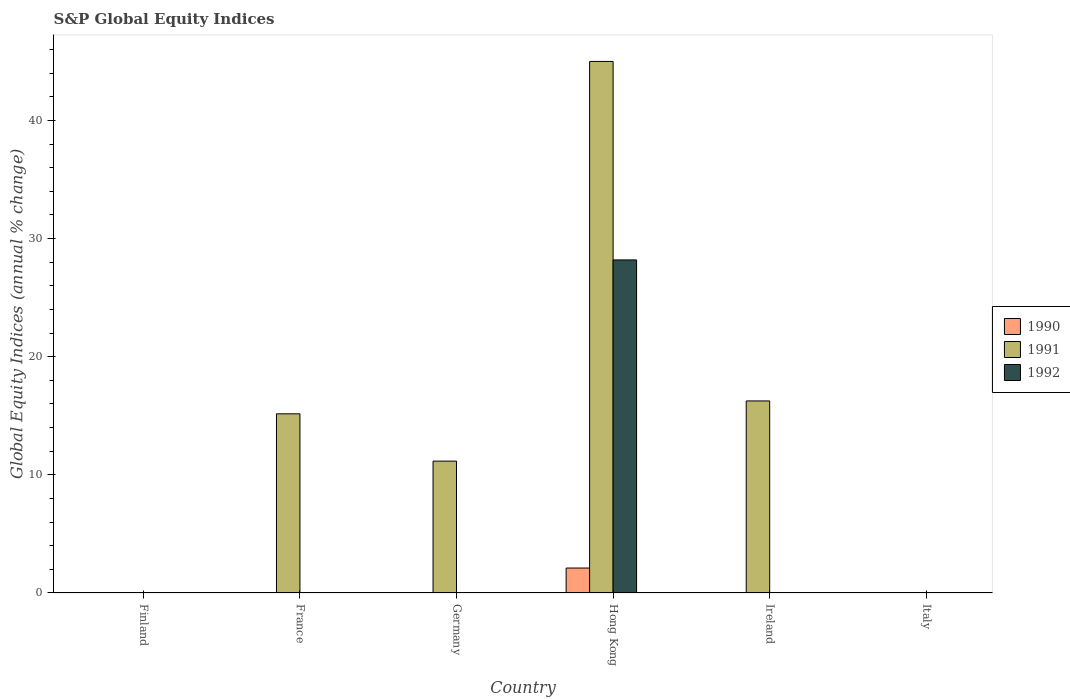Are the number of bars on each tick of the X-axis equal?
Provide a succinct answer. No. How many bars are there on the 4th tick from the left?
Your response must be concise. 3. How many bars are there on the 2nd tick from the right?
Your answer should be very brief. 1. What is the label of the 2nd group of bars from the left?
Your response must be concise. France. What is the global equity indices in 1990 in Italy?
Your answer should be very brief. 0. Across all countries, what is the maximum global equity indices in 1990?
Keep it short and to the point. 2.11. Across all countries, what is the minimum global equity indices in 1990?
Offer a terse response. 0. In which country was the global equity indices in 1991 maximum?
Provide a succinct answer. Hong Kong. What is the total global equity indices in 1992 in the graph?
Keep it short and to the point. 28.19. What is the difference between the global equity indices in 1991 in France and that in Hong Kong?
Offer a terse response. -29.83. What is the difference between the global equity indices in 1990 in Ireland and the global equity indices in 1992 in Hong Kong?
Offer a terse response. -28.19. What is the average global equity indices in 1990 per country?
Your response must be concise. 0.35. What is the difference between the global equity indices of/in 1990 and global equity indices of/in 1991 in Hong Kong?
Provide a succinct answer. -42.88. In how many countries, is the global equity indices in 1990 greater than 16 %?
Provide a succinct answer. 0. What is the ratio of the global equity indices in 1991 in France to that in Germany?
Provide a short and direct response. 1.36. Is the global equity indices in 1991 in France less than that in Hong Kong?
Your answer should be compact. Yes. What is the difference between the highest and the second highest global equity indices in 1991?
Provide a short and direct response. -28.74. What is the difference between the highest and the lowest global equity indices in 1990?
Offer a very short reply. 2.11. In how many countries, is the global equity indices in 1991 greater than the average global equity indices in 1991 taken over all countries?
Offer a terse response. 3. Is the sum of the global equity indices in 1991 in France and Germany greater than the maximum global equity indices in 1992 across all countries?
Your answer should be very brief. No. Is it the case that in every country, the sum of the global equity indices in 1992 and global equity indices in 1991 is greater than the global equity indices in 1990?
Provide a short and direct response. No. How many countries are there in the graph?
Your answer should be compact. 6. Are the values on the major ticks of Y-axis written in scientific E-notation?
Keep it short and to the point. No. Does the graph contain any zero values?
Your response must be concise. Yes. Does the graph contain grids?
Your response must be concise. No. Where does the legend appear in the graph?
Ensure brevity in your answer.  Center right. What is the title of the graph?
Offer a very short reply. S&P Global Equity Indices. Does "1969" appear as one of the legend labels in the graph?
Offer a terse response. No. What is the label or title of the X-axis?
Keep it short and to the point. Country. What is the label or title of the Y-axis?
Provide a succinct answer. Global Equity Indices (annual % change). What is the Global Equity Indices (annual % change) in 1990 in Finland?
Make the answer very short. 0. What is the Global Equity Indices (annual % change) in 1990 in France?
Your answer should be compact. 0. What is the Global Equity Indices (annual % change) of 1991 in France?
Your answer should be very brief. 15.17. What is the Global Equity Indices (annual % change) of 1992 in France?
Give a very brief answer. 0. What is the Global Equity Indices (annual % change) in 1991 in Germany?
Make the answer very short. 11.16. What is the Global Equity Indices (annual % change) of 1992 in Germany?
Offer a terse response. 0. What is the Global Equity Indices (annual % change) in 1990 in Hong Kong?
Offer a very short reply. 2.11. What is the Global Equity Indices (annual % change) in 1991 in Hong Kong?
Offer a very short reply. 44.99. What is the Global Equity Indices (annual % change) of 1992 in Hong Kong?
Provide a short and direct response. 28.19. What is the Global Equity Indices (annual % change) in 1990 in Ireland?
Your response must be concise. 0. What is the Global Equity Indices (annual % change) of 1991 in Ireland?
Provide a succinct answer. 16.26. What is the Global Equity Indices (annual % change) in 1992 in Ireland?
Your response must be concise. 0. What is the Global Equity Indices (annual % change) of 1991 in Italy?
Give a very brief answer. 0. What is the Global Equity Indices (annual % change) in 1992 in Italy?
Provide a short and direct response. 0. Across all countries, what is the maximum Global Equity Indices (annual % change) of 1990?
Ensure brevity in your answer.  2.11. Across all countries, what is the maximum Global Equity Indices (annual % change) of 1991?
Your answer should be very brief. 44.99. Across all countries, what is the maximum Global Equity Indices (annual % change) of 1992?
Offer a very short reply. 28.19. Across all countries, what is the minimum Global Equity Indices (annual % change) in 1992?
Provide a succinct answer. 0. What is the total Global Equity Indices (annual % change) in 1990 in the graph?
Your answer should be compact. 2.11. What is the total Global Equity Indices (annual % change) in 1991 in the graph?
Your response must be concise. 87.58. What is the total Global Equity Indices (annual % change) of 1992 in the graph?
Offer a very short reply. 28.19. What is the difference between the Global Equity Indices (annual % change) of 1991 in France and that in Germany?
Your response must be concise. 4. What is the difference between the Global Equity Indices (annual % change) in 1991 in France and that in Hong Kong?
Make the answer very short. -29.83. What is the difference between the Global Equity Indices (annual % change) of 1991 in France and that in Ireland?
Keep it short and to the point. -1.09. What is the difference between the Global Equity Indices (annual % change) of 1991 in Germany and that in Hong Kong?
Offer a terse response. -33.83. What is the difference between the Global Equity Indices (annual % change) in 1991 in Germany and that in Ireland?
Offer a very short reply. -5.09. What is the difference between the Global Equity Indices (annual % change) in 1991 in Hong Kong and that in Ireland?
Ensure brevity in your answer.  28.74. What is the difference between the Global Equity Indices (annual % change) in 1991 in France and the Global Equity Indices (annual % change) in 1992 in Hong Kong?
Your answer should be compact. -13.03. What is the difference between the Global Equity Indices (annual % change) of 1991 in Germany and the Global Equity Indices (annual % change) of 1992 in Hong Kong?
Ensure brevity in your answer.  -17.03. What is the difference between the Global Equity Indices (annual % change) in 1990 in Hong Kong and the Global Equity Indices (annual % change) in 1991 in Ireland?
Offer a terse response. -14.14. What is the average Global Equity Indices (annual % change) in 1990 per country?
Keep it short and to the point. 0.35. What is the average Global Equity Indices (annual % change) of 1991 per country?
Make the answer very short. 14.6. What is the average Global Equity Indices (annual % change) of 1992 per country?
Give a very brief answer. 4.7. What is the difference between the Global Equity Indices (annual % change) in 1990 and Global Equity Indices (annual % change) in 1991 in Hong Kong?
Your response must be concise. -42.88. What is the difference between the Global Equity Indices (annual % change) in 1990 and Global Equity Indices (annual % change) in 1992 in Hong Kong?
Offer a terse response. -26.08. What is the difference between the Global Equity Indices (annual % change) in 1991 and Global Equity Indices (annual % change) in 1992 in Hong Kong?
Offer a terse response. 16.8. What is the ratio of the Global Equity Indices (annual % change) in 1991 in France to that in Germany?
Your answer should be compact. 1.36. What is the ratio of the Global Equity Indices (annual % change) of 1991 in France to that in Hong Kong?
Your response must be concise. 0.34. What is the ratio of the Global Equity Indices (annual % change) of 1991 in France to that in Ireland?
Offer a terse response. 0.93. What is the ratio of the Global Equity Indices (annual % change) in 1991 in Germany to that in Hong Kong?
Give a very brief answer. 0.25. What is the ratio of the Global Equity Indices (annual % change) in 1991 in Germany to that in Ireland?
Offer a terse response. 0.69. What is the ratio of the Global Equity Indices (annual % change) of 1991 in Hong Kong to that in Ireland?
Your answer should be compact. 2.77. What is the difference between the highest and the second highest Global Equity Indices (annual % change) in 1991?
Give a very brief answer. 28.74. What is the difference between the highest and the lowest Global Equity Indices (annual % change) in 1990?
Your response must be concise. 2.11. What is the difference between the highest and the lowest Global Equity Indices (annual % change) of 1991?
Your answer should be compact. 44.99. What is the difference between the highest and the lowest Global Equity Indices (annual % change) of 1992?
Ensure brevity in your answer.  28.19. 